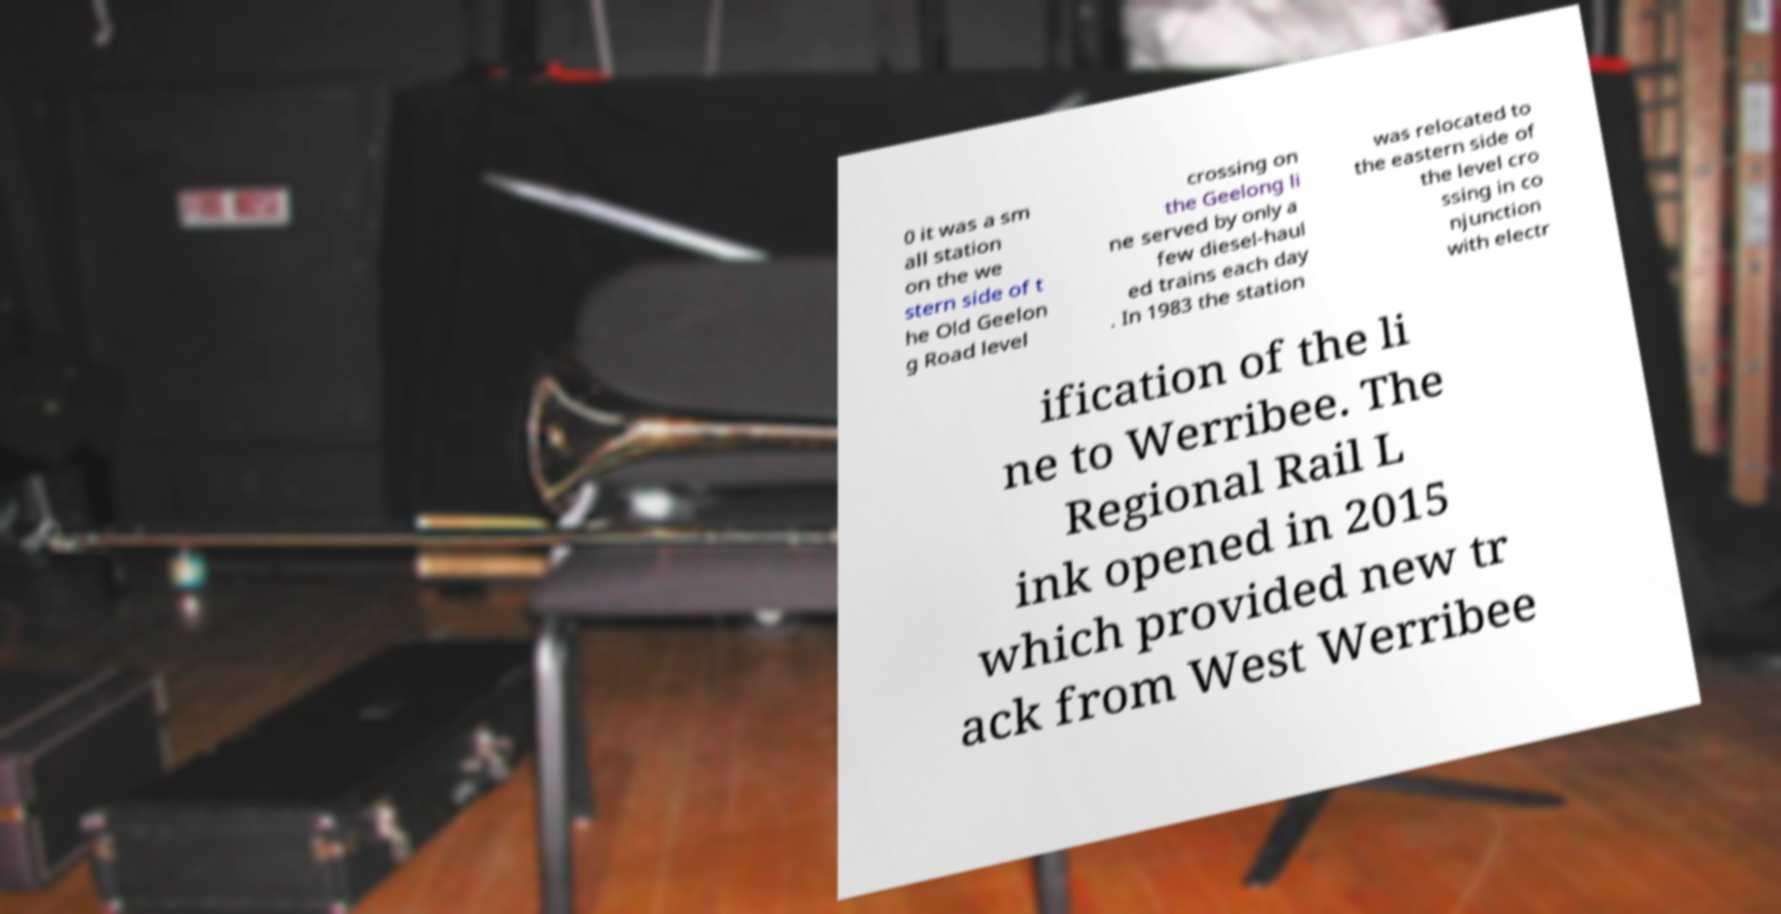For documentation purposes, I need the text within this image transcribed. Could you provide that? 0 it was a sm all station on the we stern side of t he Old Geelon g Road level crossing on the Geelong li ne served by only a few diesel-haul ed trains each day . In 1983 the station was relocated to the eastern side of the level cro ssing in co njunction with electr ification of the li ne to Werribee. The Regional Rail L ink opened in 2015 which provided new tr ack from West Werribee 